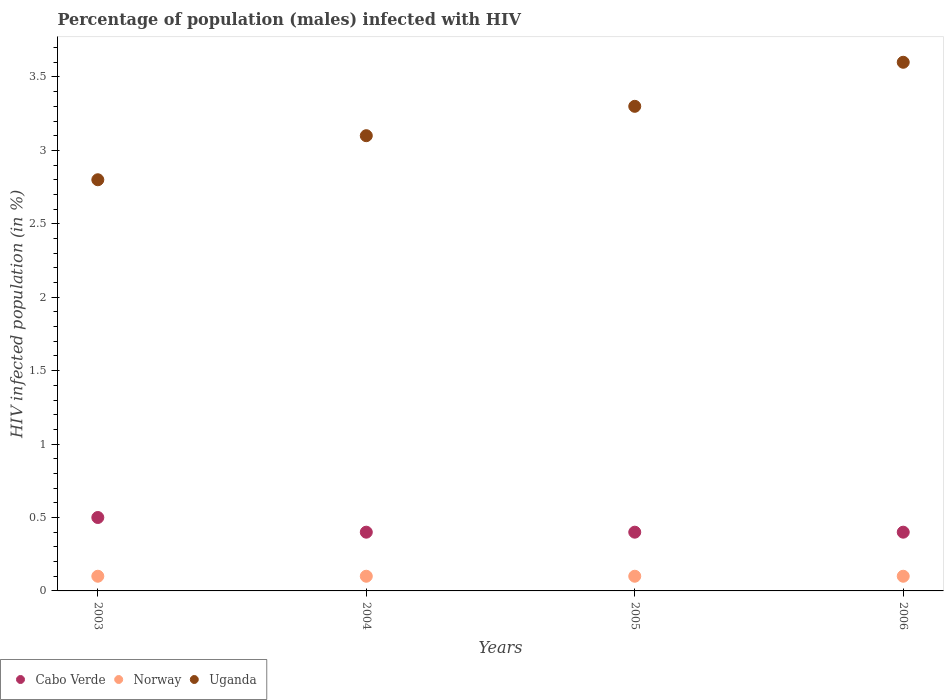Is the number of dotlines equal to the number of legend labels?
Your answer should be compact. Yes. What is the percentage of HIV infected male population in Cabo Verde in 2003?
Offer a very short reply. 0.5. In which year was the percentage of HIV infected male population in Norway minimum?
Provide a short and direct response. 2003. What is the total percentage of HIV infected male population in Uganda in the graph?
Ensure brevity in your answer.  12.8. What is the difference between the percentage of HIV infected male population in Uganda in 2004 and the percentage of HIV infected male population in Cabo Verde in 2005?
Your answer should be very brief. 2.7. What is the average percentage of HIV infected male population in Norway per year?
Your answer should be very brief. 0.1. In the year 2003, what is the difference between the percentage of HIV infected male population in Uganda and percentage of HIV infected male population in Cabo Verde?
Provide a succinct answer. 2.3. In how many years, is the percentage of HIV infected male population in Uganda greater than 0.9 %?
Provide a succinct answer. 4. Is the percentage of HIV infected male population in Uganda in 2003 less than that in 2005?
Provide a short and direct response. Yes. Is the difference between the percentage of HIV infected male population in Uganda in 2003 and 2006 greater than the difference between the percentage of HIV infected male population in Cabo Verde in 2003 and 2006?
Provide a short and direct response. No. What is the difference between the highest and the second highest percentage of HIV infected male population in Cabo Verde?
Offer a very short reply. 0.1. In how many years, is the percentage of HIV infected male population in Norway greater than the average percentage of HIV infected male population in Norway taken over all years?
Provide a short and direct response. 0. Does the percentage of HIV infected male population in Cabo Verde monotonically increase over the years?
Your answer should be very brief. No. Are the values on the major ticks of Y-axis written in scientific E-notation?
Offer a very short reply. No. Where does the legend appear in the graph?
Offer a terse response. Bottom left. How many legend labels are there?
Keep it short and to the point. 3. What is the title of the graph?
Provide a succinct answer. Percentage of population (males) infected with HIV. Does "Morocco" appear as one of the legend labels in the graph?
Provide a succinct answer. No. What is the label or title of the X-axis?
Provide a succinct answer. Years. What is the label or title of the Y-axis?
Your response must be concise. HIV infected population (in %). What is the HIV infected population (in %) in Cabo Verde in 2004?
Your answer should be very brief. 0.4. What is the HIV infected population (in %) in Uganda in 2005?
Offer a very short reply. 3.3. What is the HIV infected population (in %) in Cabo Verde in 2006?
Offer a very short reply. 0.4. What is the HIV infected population (in %) of Norway in 2006?
Your answer should be very brief. 0.1. Across all years, what is the maximum HIV infected population (in %) in Cabo Verde?
Give a very brief answer. 0.5. Across all years, what is the maximum HIV infected population (in %) of Uganda?
Your answer should be very brief. 3.6. Across all years, what is the minimum HIV infected population (in %) in Uganda?
Make the answer very short. 2.8. What is the total HIV infected population (in %) in Cabo Verde in the graph?
Provide a short and direct response. 1.7. What is the total HIV infected population (in %) of Norway in the graph?
Ensure brevity in your answer.  0.4. What is the difference between the HIV infected population (in %) of Cabo Verde in 2004 and that in 2006?
Provide a succinct answer. 0. What is the difference between the HIV infected population (in %) in Norway in 2004 and that in 2006?
Offer a very short reply. 0. What is the difference between the HIV infected population (in %) in Uganda in 2004 and that in 2006?
Ensure brevity in your answer.  -0.5. What is the difference between the HIV infected population (in %) in Cabo Verde in 2005 and that in 2006?
Offer a terse response. 0. What is the difference between the HIV infected population (in %) in Norway in 2005 and that in 2006?
Keep it short and to the point. 0. What is the difference between the HIV infected population (in %) of Cabo Verde in 2003 and the HIV infected population (in %) of Uganda in 2004?
Your response must be concise. -2.6. What is the difference between the HIV infected population (in %) in Norway in 2003 and the HIV infected population (in %) in Uganda in 2004?
Offer a terse response. -3. What is the difference between the HIV infected population (in %) in Cabo Verde in 2003 and the HIV infected population (in %) in Uganda in 2005?
Your answer should be compact. -2.8. What is the difference between the HIV infected population (in %) in Cabo Verde in 2003 and the HIV infected population (in %) in Norway in 2006?
Your response must be concise. 0.4. What is the difference between the HIV infected population (in %) in Norway in 2003 and the HIV infected population (in %) in Uganda in 2006?
Keep it short and to the point. -3.5. What is the difference between the HIV infected population (in %) in Cabo Verde in 2004 and the HIV infected population (in %) in Norway in 2005?
Your answer should be very brief. 0.3. What is the difference between the HIV infected population (in %) in Norway in 2004 and the HIV infected population (in %) in Uganda in 2005?
Keep it short and to the point. -3.2. What is the difference between the HIV infected population (in %) of Norway in 2004 and the HIV infected population (in %) of Uganda in 2006?
Ensure brevity in your answer.  -3.5. What is the difference between the HIV infected population (in %) of Norway in 2005 and the HIV infected population (in %) of Uganda in 2006?
Offer a terse response. -3.5. What is the average HIV infected population (in %) in Cabo Verde per year?
Give a very brief answer. 0.42. In the year 2003, what is the difference between the HIV infected population (in %) of Norway and HIV infected population (in %) of Uganda?
Your response must be concise. -2.7. In the year 2004, what is the difference between the HIV infected population (in %) of Cabo Verde and HIV infected population (in %) of Uganda?
Offer a very short reply. -2.7. In the year 2004, what is the difference between the HIV infected population (in %) of Norway and HIV infected population (in %) of Uganda?
Provide a succinct answer. -3. In the year 2005, what is the difference between the HIV infected population (in %) in Cabo Verde and HIV infected population (in %) in Norway?
Provide a short and direct response. 0.3. In the year 2005, what is the difference between the HIV infected population (in %) of Cabo Verde and HIV infected population (in %) of Uganda?
Provide a succinct answer. -2.9. In the year 2006, what is the difference between the HIV infected population (in %) in Cabo Verde and HIV infected population (in %) in Norway?
Your answer should be very brief. 0.3. In the year 2006, what is the difference between the HIV infected population (in %) in Cabo Verde and HIV infected population (in %) in Uganda?
Keep it short and to the point. -3.2. What is the ratio of the HIV infected population (in %) in Cabo Verde in 2003 to that in 2004?
Your answer should be very brief. 1.25. What is the ratio of the HIV infected population (in %) of Norway in 2003 to that in 2004?
Provide a short and direct response. 1. What is the ratio of the HIV infected population (in %) of Uganda in 2003 to that in 2004?
Ensure brevity in your answer.  0.9. What is the ratio of the HIV infected population (in %) of Cabo Verde in 2003 to that in 2005?
Offer a very short reply. 1.25. What is the ratio of the HIV infected population (in %) in Norway in 2003 to that in 2005?
Keep it short and to the point. 1. What is the ratio of the HIV infected population (in %) of Uganda in 2003 to that in 2005?
Your answer should be compact. 0.85. What is the ratio of the HIV infected population (in %) in Cabo Verde in 2003 to that in 2006?
Provide a succinct answer. 1.25. What is the ratio of the HIV infected population (in %) of Uganda in 2003 to that in 2006?
Keep it short and to the point. 0.78. What is the ratio of the HIV infected population (in %) in Norway in 2004 to that in 2005?
Give a very brief answer. 1. What is the ratio of the HIV infected population (in %) in Uganda in 2004 to that in 2005?
Provide a short and direct response. 0.94. What is the ratio of the HIV infected population (in %) in Uganda in 2004 to that in 2006?
Provide a succinct answer. 0.86. What is the ratio of the HIV infected population (in %) in Cabo Verde in 2005 to that in 2006?
Your response must be concise. 1. What is the ratio of the HIV infected population (in %) of Norway in 2005 to that in 2006?
Keep it short and to the point. 1. What is the difference between the highest and the second highest HIV infected population (in %) in Cabo Verde?
Make the answer very short. 0.1. What is the difference between the highest and the lowest HIV infected population (in %) of Uganda?
Your answer should be compact. 0.8. 